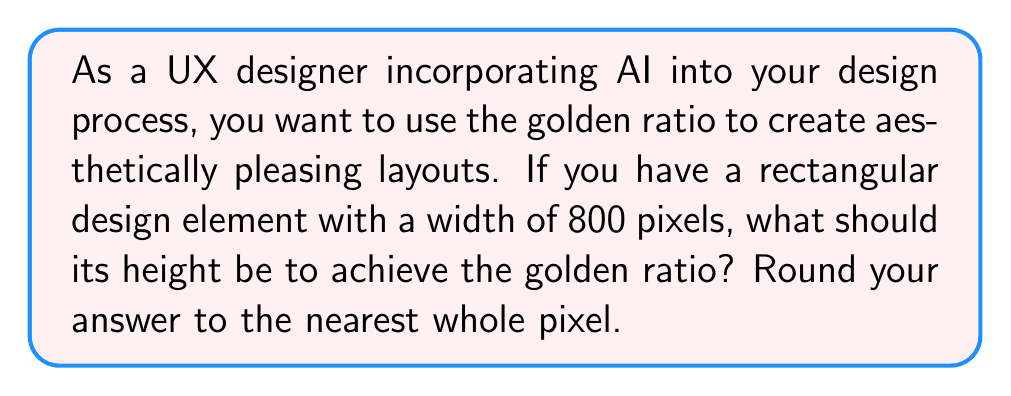Can you answer this question? The golden ratio, denoted by the Greek letter phi (φ), is approximately 1.618033988749895. In design, this ratio is often used to create visually appealing proportions.

For a rectangle to have the golden ratio, the ratio of its length to its width should be equal to φ. In this case, we have the width and need to calculate the height.

Let's define our variables:
$w$ = width
$h$ = height

The golden ratio equation for a rectangle is:

$$ \frac{w + h}{w} = φ $$

We know the width is 800 pixels, so let's substitute this value:

$$ \frac{800 + h}{800} = φ $$

Now, let's solve for h:

$$ 800 + h = 800φ $$
$$ h = 800φ - 800 $$
$$ h = 800(φ - 1) $$

We can now substitute the value of φ:

$$ h = 800(1.618033988749895 - 1) $$
$$ h = 800(0.618033988749895) $$
$$ h = 494.427191 $$

Rounding to the nearest whole pixel:

$$ h ≈ 494 \text{ pixels} $$

This result means that for a width of 800 pixels, a height of 494 pixels will create a rectangle with proportions very close to the golden ratio.
Answer: 494 pixels 